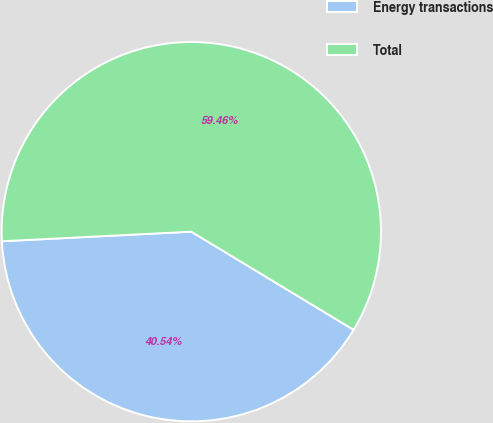<chart> <loc_0><loc_0><loc_500><loc_500><pie_chart><fcel>Energy transactions<fcel>Total<nl><fcel>40.54%<fcel>59.46%<nl></chart> 